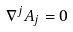<formula> <loc_0><loc_0><loc_500><loc_500>\nabla ^ { j } { A } _ { j } = 0</formula> 